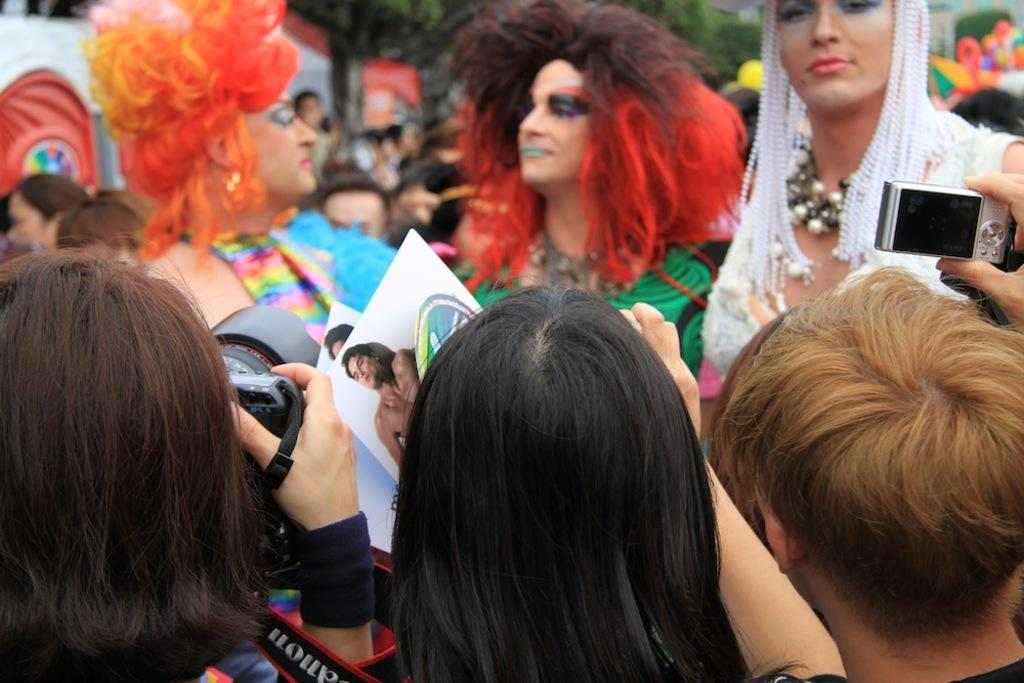What are the three people in the image doing? The three people in the image are holding cameras. What might be happening in the image? It appears that the camera-holding individuals are taking pictures of other people in front of them. What can be seen in the background of the image? There are trees in the background of the image. How many wrists are visible in the image? There is no specific mention of wrists in the image, so it is not possible to determine the number of wrists visible. 